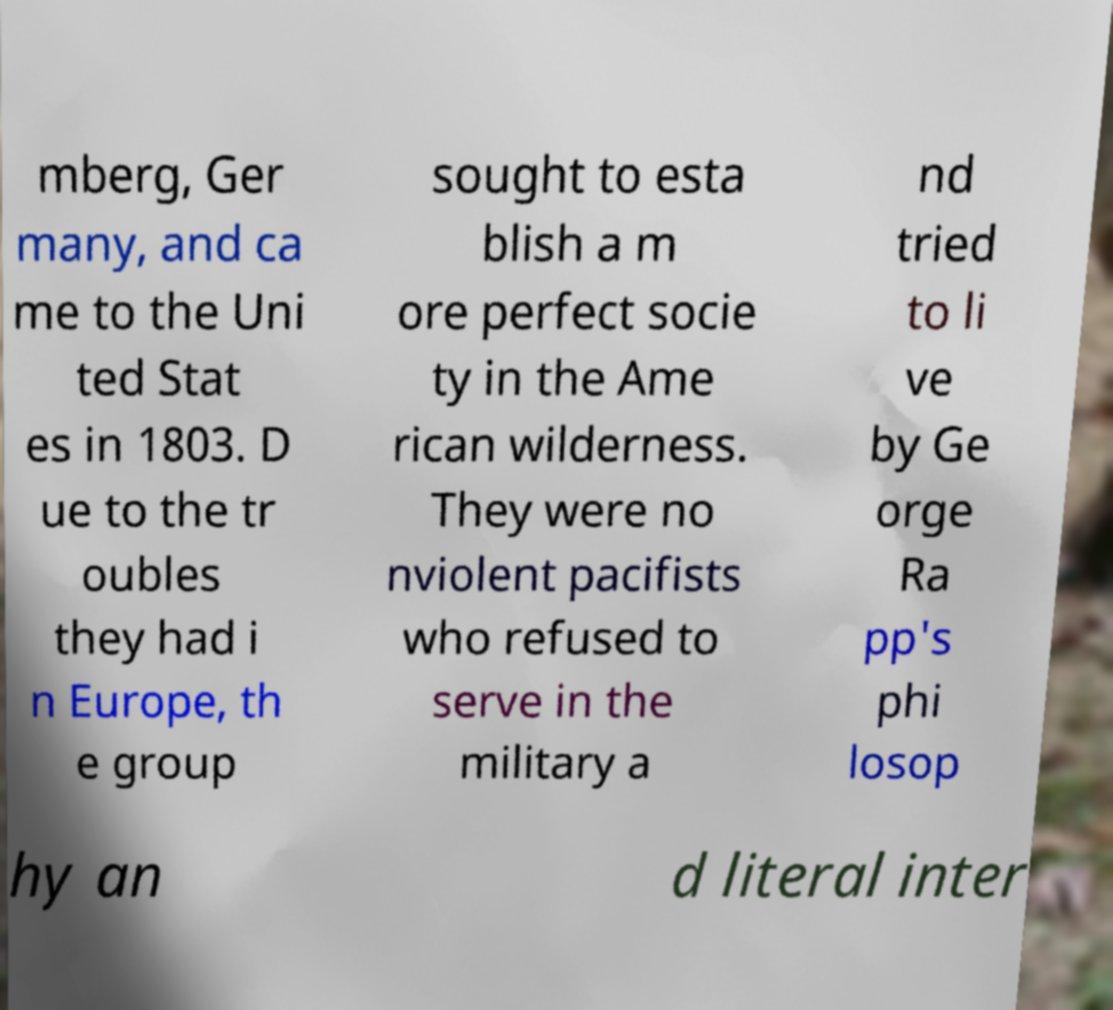Can you read and provide the text displayed in the image?This photo seems to have some interesting text. Can you extract and type it out for me? mberg, Ger many, and ca me to the Uni ted Stat es in 1803. D ue to the tr oubles they had i n Europe, th e group sought to esta blish a m ore perfect socie ty in the Ame rican wilderness. They were no nviolent pacifists who refused to serve in the military a nd tried to li ve by Ge orge Ra pp's phi losop hy an d literal inter 